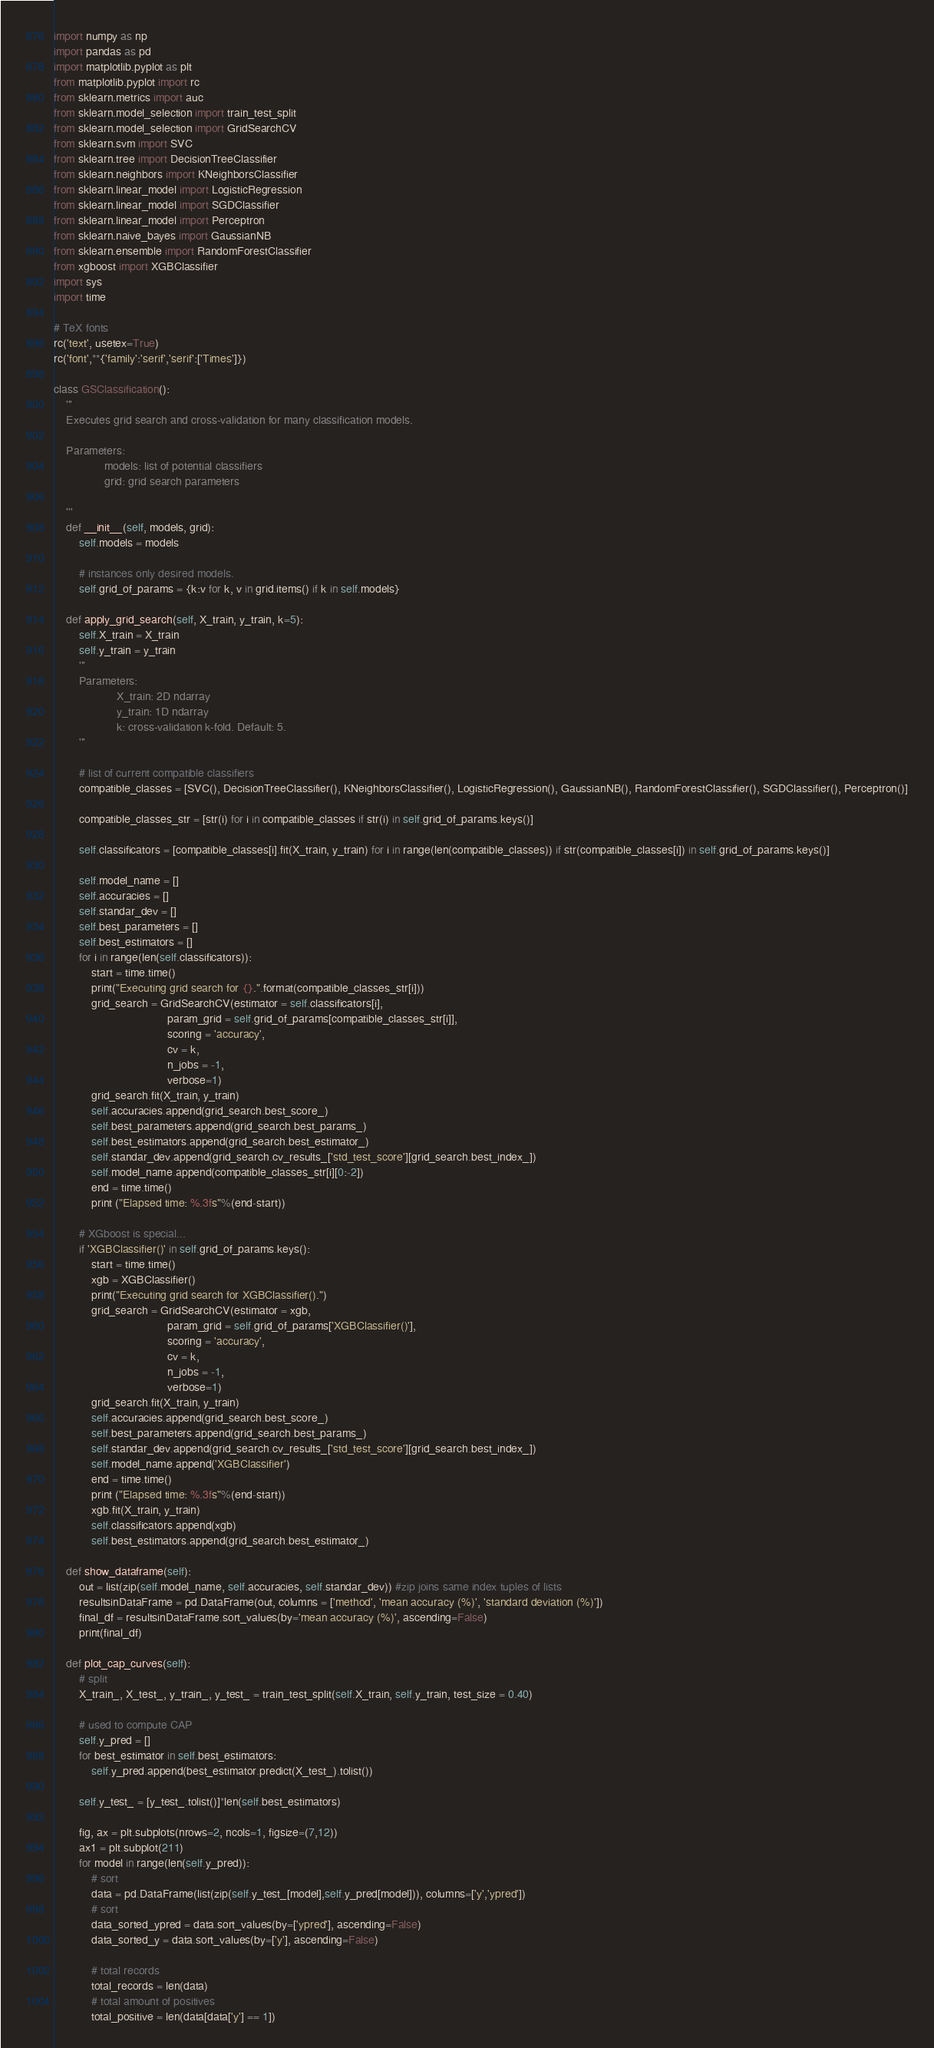Convert code to text. <code><loc_0><loc_0><loc_500><loc_500><_Python_>import numpy as np
import pandas as pd
import matplotlib.pyplot as plt
from matplotlib.pyplot import rc
from sklearn.metrics import auc
from sklearn.model_selection import train_test_split
from sklearn.model_selection import GridSearchCV
from sklearn.svm import SVC
from sklearn.tree import DecisionTreeClassifier
from sklearn.neighbors import KNeighborsClassifier
from sklearn.linear_model import LogisticRegression
from sklearn.linear_model import SGDClassifier
from sklearn.linear_model import Perceptron
from sklearn.naive_bayes import GaussianNB
from sklearn.ensemble import RandomForestClassifier
from xgboost import XGBClassifier
import sys
import time

# TeX fonts
rc('text', usetex=True)
rc('font',**{'family':'serif','serif':['Times']})

class GSClassification():
    '''
    Executes grid search and cross-validation for many classification models.
    
    Parameters: 
                models: list of potential classifiers
                grid: grid search parameters
                
    '''
    def __init__(self, models, grid):
        self.models = models
        
        # instances only desired models.
        self.grid_of_params = {k:v for k, v in grid.items() if k in self.models}
        
    def apply_grid_search(self, X_train, y_train, k=5):
        self.X_train = X_train
        self.y_train = y_train
        '''
        Parameters: 
                    X_train: 2D ndarray
                    y_train: 1D ndarray                
                    k: cross-validation k-fold. Default: 5.
        '''
        
        # list of current compatible classifiers
        compatible_classes = [SVC(), DecisionTreeClassifier(), KNeighborsClassifier(), LogisticRegression(), GaussianNB(), RandomForestClassifier(), SGDClassifier(), Perceptron()]

        compatible_classes_str = [str(i) for i in compatible_classes if str(i) in self.grid_of_params.keys()]

        self.classificators = [compatible_classes[i].fit(X_train, y_train) for i in range(len(compatible_classes)) if str(compatible_classes[i]) in self.grid_of_params.keys()]
        
        self.model_name = []
        self.accuracies = []
        self.standar_dev = []
        self.best_parameters = []
        self.best_estimators = []
        for i in range(len(self.classificators)):
            start = time.time()
            print("Executing grid search for {}.".format(compatible_classes_str[i]))
            grid_search = GridSearchCV(estimator = self.classificators[i],
                                    param_grid = self.grid_of_params[compatible_classes_str[i]],
                                    scoring = 'accuracy',
                                    cv = k,
                                    n_jobs = -1,
                                    verbose=1)
            grid_search.fit(X_train, y_train)
            self.accuracies.append(grid_search.best_score_)
            self.best_parameters.append(grid_search.best_params_)
            self.best_estimators.append(grid_search.best_estimator_)
            self.standar_dev.append(grid_search.cv_results_['std_test_score'][grid_search.best_index_])
            self.model_name.append(compatible_classes_str[i][0:-2])
            end = time.time()
            print ("Elapsed time: %.3fs"%(end-start))
            
        # XGboost is special...
        if 'XGBClassifier()' in self.grid_of_params.keys():
            start = time.time()
            xgb = XGBClassifier()
            print("Executing grid search for XGBClassifier().")
            grid_search = GridSearchCV(estimator = xgb,
                                    param_grid = self.grid_of_params['XGBClassifier()'],
                                    scoring = 'accuracy',
                                    cv = k,
                                    n_jobs = -1,
                                    verbose=1)
            grid_search.fit(X_train, y_train)
            self.accuracies.append(grid_search.best_score_)
            self.best_parameters.append(grid_search.best_params_)
            self.standar_dev.append(grid_search.cv_results_['std_test_score'][grid_search.best_index_])
            self.model_name.append('XGBClassifier')
            end = time.time()
            print ("Elapsed time: %.3fs"%(end-start))
            xgb.fit(X_train, y_train)
            self.classificators.append(xgb)
            self.best_estimators.append(grid_search.best_estimator_)
    
    def show_dataframe(self):
        out = list(zip(self.model_name, self.accuracies, self.standar_dev)) #zip joins same index tuples of lists
        resultsinDataFrame = pd.DataFrame(out, columns = ['method', 'mean accuracy (%)', 'standard deviation (%)'])
        final_df = resultsinDataFrame.sort_values(by='mean accuracy (%)', ascending=False)
        print(final_df)
        
    def plot_cap_curves(self):
        # split
        X_train_, X_test_, y_train_, y_test_ = train_test_split(self.X_train, self.y_train, test_size = 0.40)
        
        # used to compute CAP
        self.y_pred = []
        for best_estimator in self.best_estimators:
            self.y_pred.append(best_estimator.predict(X_test_).tolist())

        self.y_test_ = [y_test_.tolist()]*len(self.best_estimators)
        
        fig, ax = plt.subplots(nrows=2, ncols=1, figsize=(7,12))
        ax1 = plt.subplot(211)
        for model in range(len(self.y_pred)):
            # sort
            data = pd.DataFrame(list(zip(self.y_test_[model],self.y_pred[model])), columns=['y','ypred'])
            # sort
            data_sorted_ypred = data.sort_values(by=['ypred'], ascending=False)
            data_sorted_y = data.sort_values(by=['y'], ascending=False)

            # total records
            total_records = len(data)
            # total amount of positives
            total_positive = len(data[data['y'] == 1])
</code> 